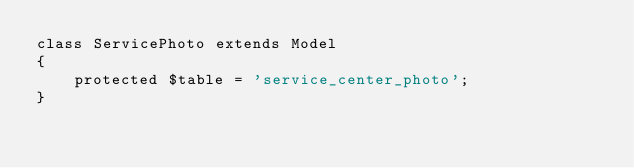Convert code to text. <code><loc_0><loc_0><loc_500><loc_500><_PHP_>class ServicePhoto extends Model
{
    protected $table = 'service_center_photo';
}
</code> 